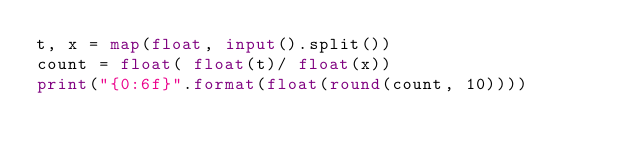<code> <loc_0><loc_0><loc_500><loc_500><_Python_>t, x = map(float, input().split())
count = float( float(t)/ float(x))
print("{0:6f}".format(float(round(count, 10))))</code> 